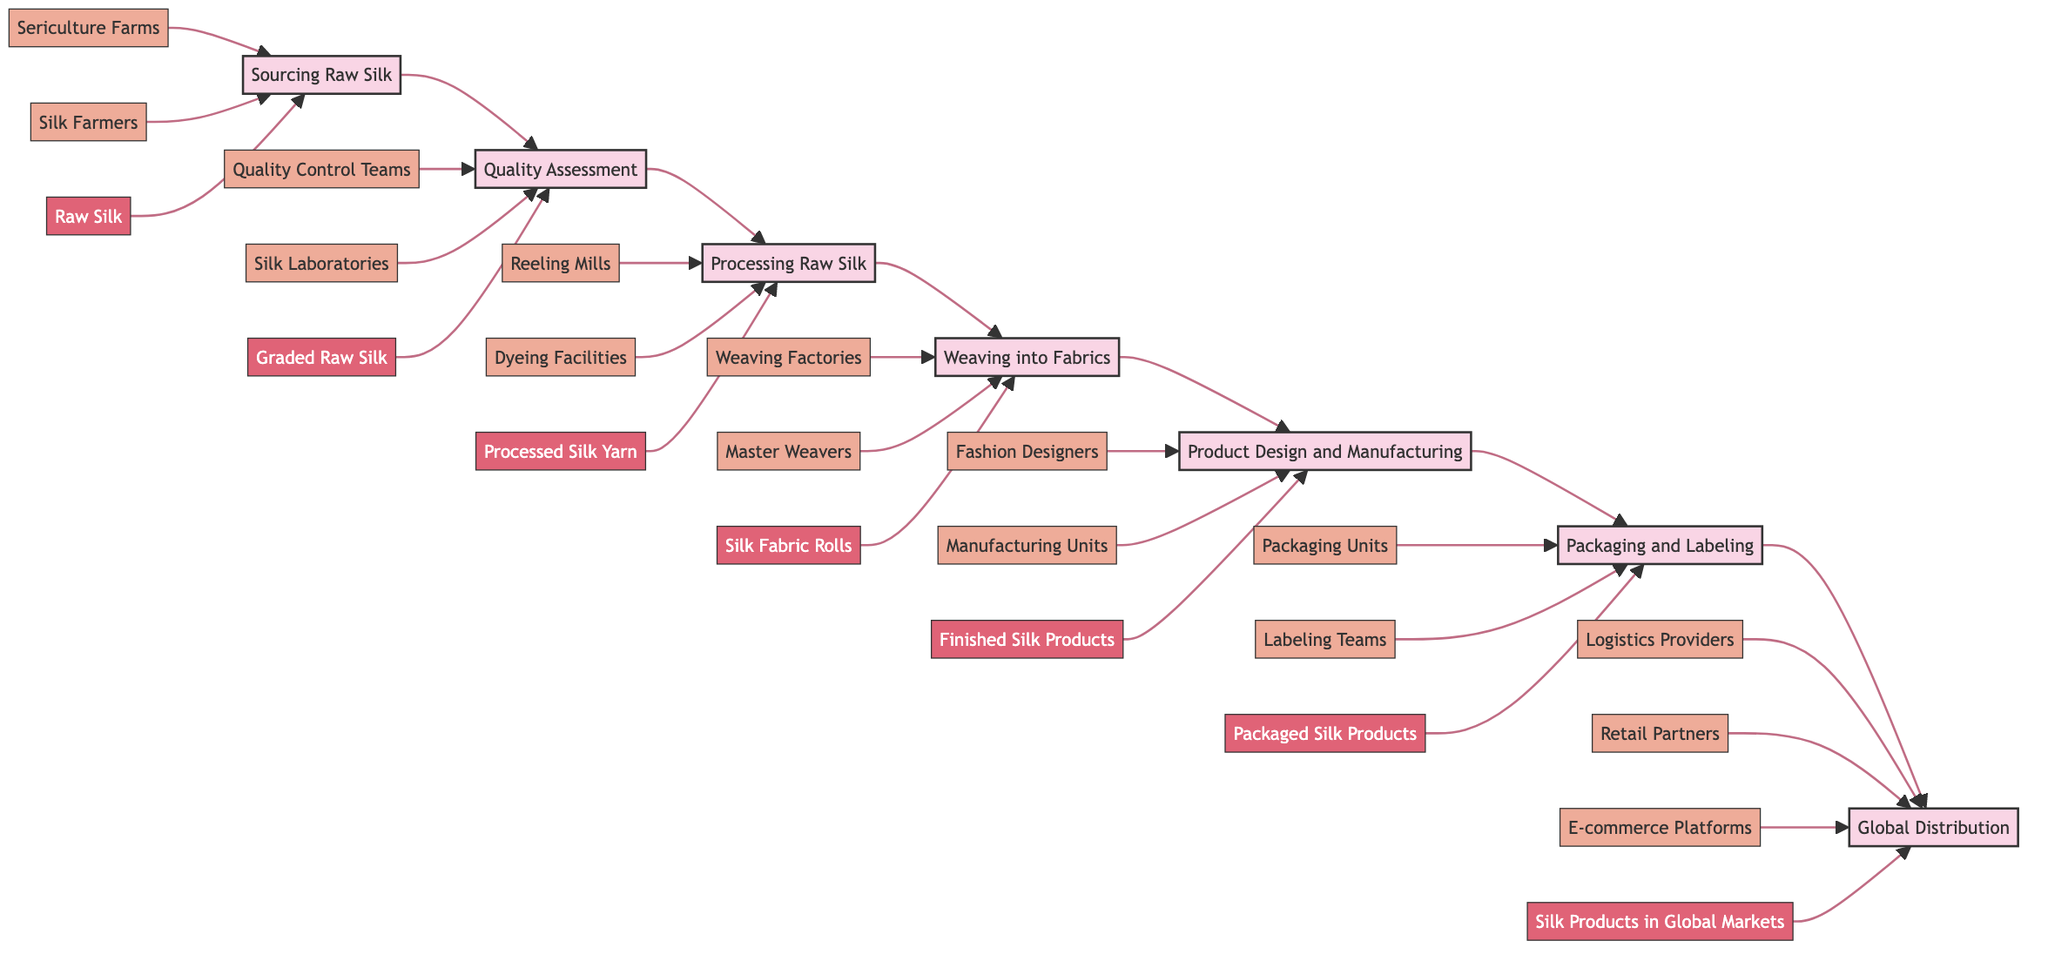What is the first step in the silk production process? The diagram shows that the first step in the silk production process is "Sourcing Raw Silk." This step initiates the flowchart and is located at the leftmost position.
Answer: Sourcing Raw Silk How many key entities are involved in the "Processing Raw Silk" step? In the "Processing Raw Silk" step, there are two key entities listed: "Reeling Mills" and "Dyeing Facilities." This can be counted directly from the diagram.
Answer: 2 What is the output after "Packaging and Labeling"? According to the diagram, the output after the "Packaging and Labeling" step is "Packaged Silk Products." This is indicated as the result of this particular step.
Answer: Packaged Silk Products Which step directly follows "Weaving into Fabrics"? The diagram indicates that "Product Design and Manufacturing" comes directly after the "Weaving into Fabrics" step. This shows the sequential nature of the process.
Answer: Product Design and Manufacturing What are the key entities in the "Quality Assessment" step? The diagram lists two key entities involved in the "Quality Assessment" step: "Quality Control Teams" and "Silk Laboratories." These entities are shown as connected to this step, indicating their involvement.
Answer: Quality Control Teams, Silk Laboratories How many steps are there in total from Sourcing Raw Silk to Global Distribution? By counting each step in the flowchart, it can be identified that there are seven steps total, from "Sourcing Raw Silk" through to "Global Distribution."
Answer: 7 Which step results in "Finished Silk Products"? The diagram shows that "Product Design and Manufacturing" is the step that produces "Finished Silk Products" as the output. This can be confirmed by following the flow from the previous steps.
Answer: Product Design and Manufacturing What is the role of "Logistics Providers" in this process? "Logistics Providers" are key entities involved in the final step, "Global Distribution," of the silk production process, facilitating the distribution of products to global markets.
Answer: Global Distribution What follows after "Processed Silk Yarn"? According to the flowchart, "Weaving into Fabrics" follows directly after the "Processed Silk Yarn" step, as indicated by the arrows showing the flow of the process.
Answer: Weaving into Fabrics 